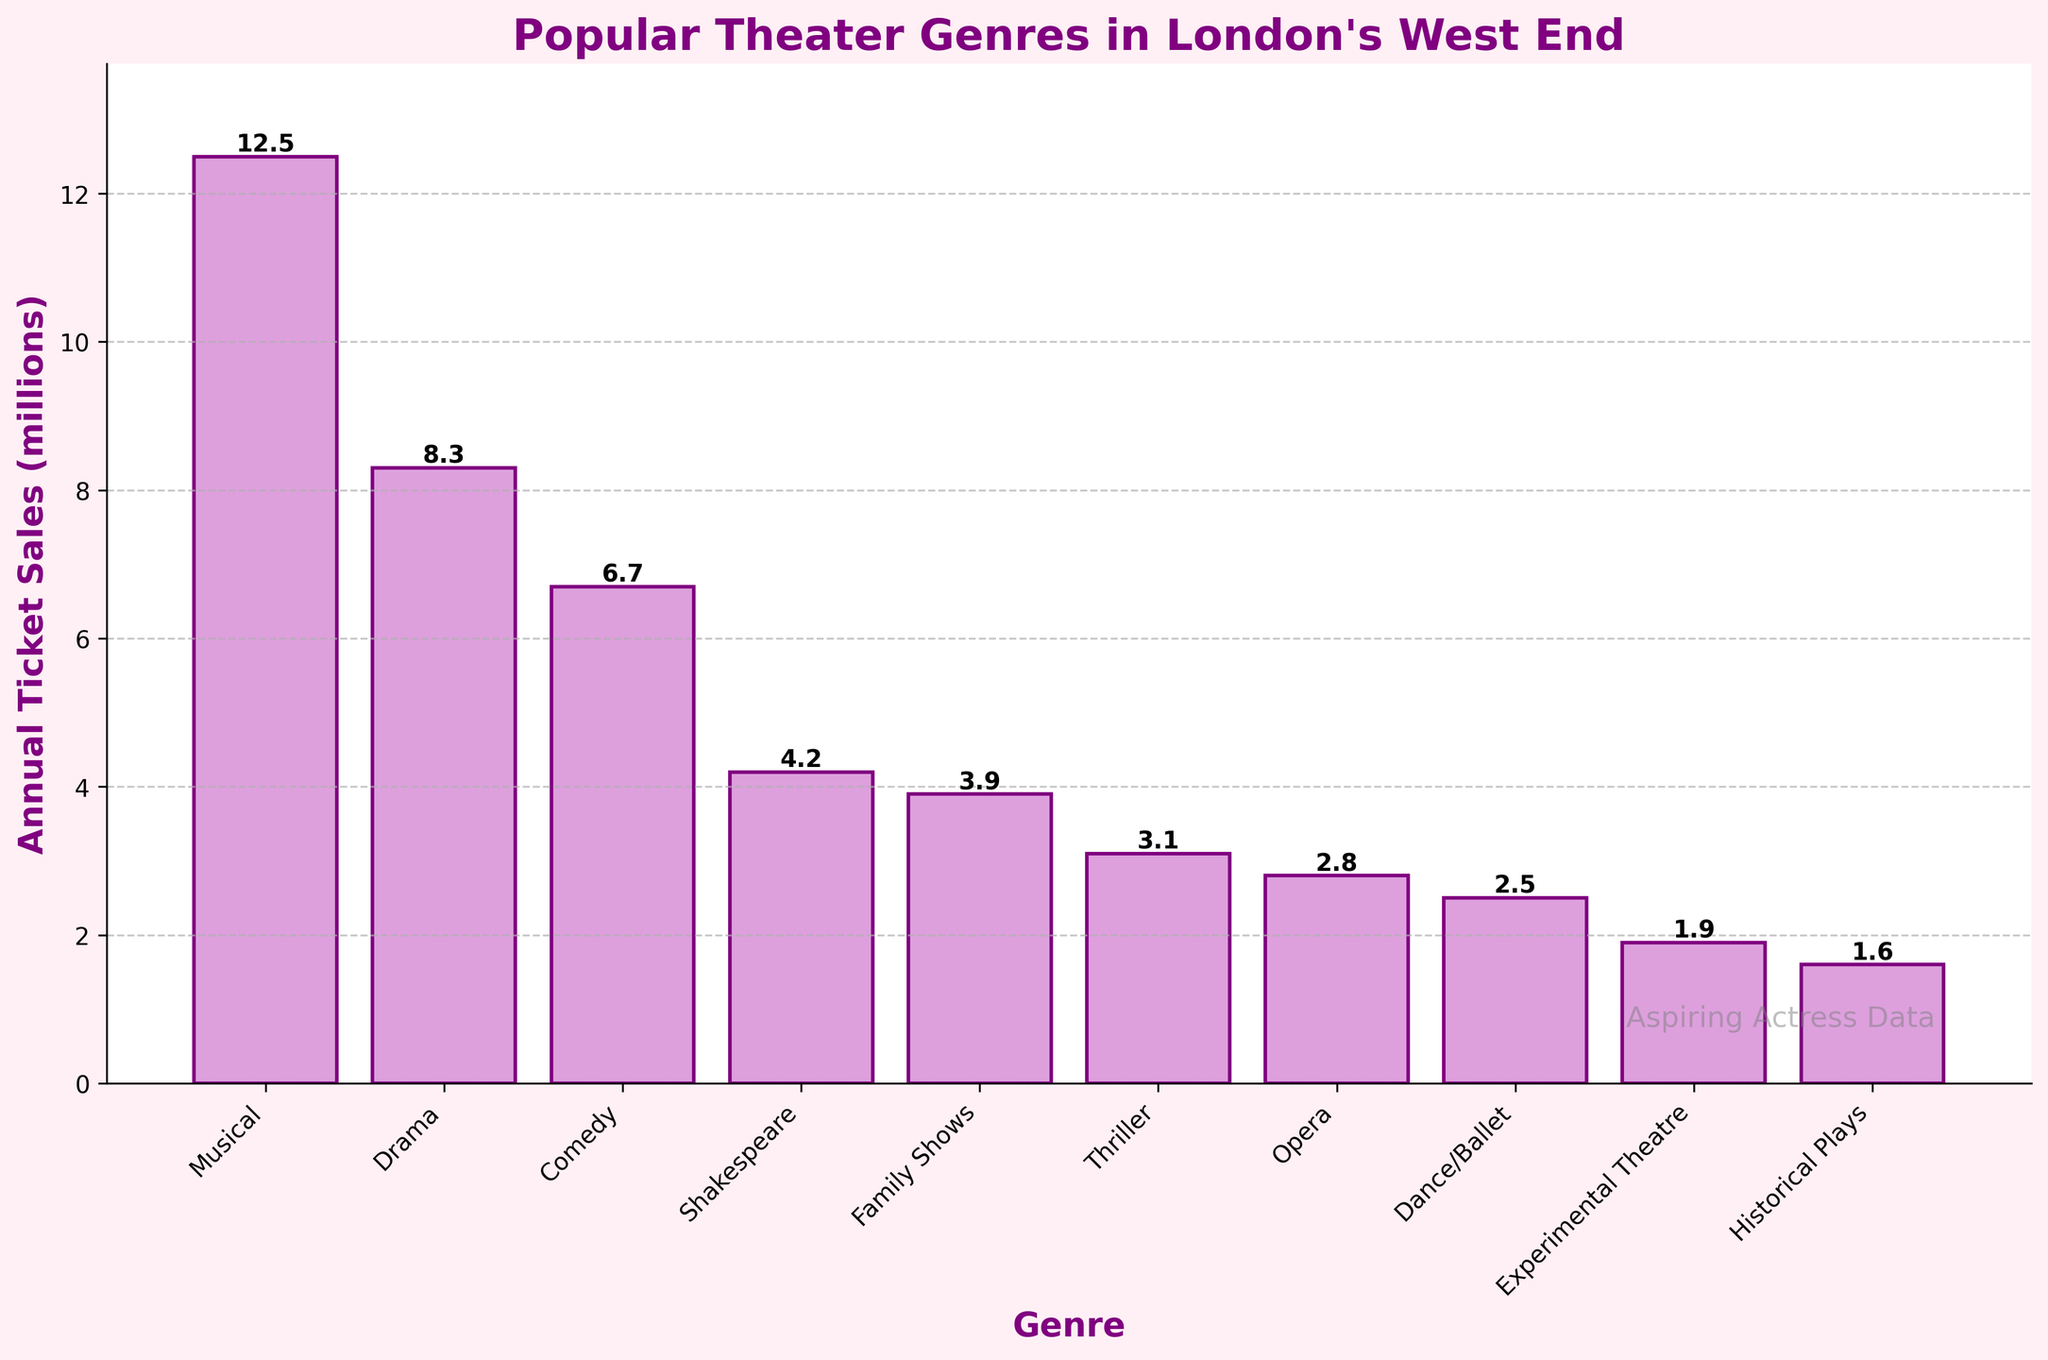Which theater genre has the highest annual ticket sales? The highest bar represents the genre with the highest sales. In this case, the bar for Musicals is the tallest.
Answer: Musical What's the difference in annual ticket sales between Musicals and Dramas? The annual ticket sales for Musicals is 12.5 million and for Dramas is 8.3 million. Subtracting these values yields the difference of 12.5 - 8.3 = 4.2 million.
Answer: 4.2 million Which genre has higher annual ticket sales: Comedy or Thriller? The bar for Comedy is taller than the bar for Thriller. Comedy has 6.7 million in ticket sales, while Thriller has 3.1 million.
Answer: Comedy What's the combined annual ticket sales of Family Shows and Dance/Ballet? Annual ticket sales for Family Shows are 3.9 million and for Dance/Ballet are 2.5 million. Adding these values gives 3.9 + 2.5 = 6.4 million.
Answer: 6.4 million How much more popular are Musicals compared to Experimental Theatre in terms of annual ticket sales? Musicals have 12.5 million in ticket sales whereas Experimental Theatre has 1.9 million. The difference is 12.5 - 1.9 = 10.6 million.
Answer: 10.6 million Which genre has the lowest annual ticket sales? The shortest bar in the bar chart indicates the genre with the lowest sales. Here, Historical Plays has the shortest bar with 1.6 million in sales.
Answer: Historical Plays What's the average annual ticket sales for Opera and Shakespeare genres combined? Opera has 2.8 million in sales and Shakespeare has 4.2 million. The combined sales are 2.8 + 4.2 = 7 million. The average is 7 / 2 = 3.5 million.
Answer: 3.5 million How many genres have annual ticket sales below 4 million? The bars for Family Shows (3.9), Thriller (3.1), Opera (2.8), Dance/Ballet (2.5), Experimental Theatre (1.9), and Historical Plays (1.6) are all below the 4 million mark. There are 6 genres in total.
Answer: 6 Are there more genres with annual ticket sales above 5 million or below 5 million? Genres with sales above 5 million: Musical, Drama, and Comedy (3 genres). Genres with sales below 5 million: Shakespeare, Family Shows, Thriller, Opera, Dance/Ballet, Experimental Theatre, and Historical Plays (7 genres).
Answer: Below 5 million Which genres have annual ticket sales less than half of Comedy's sales? Comedy has 6.7 million in annual ticket sales. Half of that is 3.35 million. Genres with sales less than 3.35 million are Thriller (3.1), Opera (2.8), Dance/Ballet (2.5), Experimental Theatre (1.9), Historical Plays (1.6).
Answer: Thriller, Opera, Dance/Ballet, Experimental Theatre, Historical Plays 